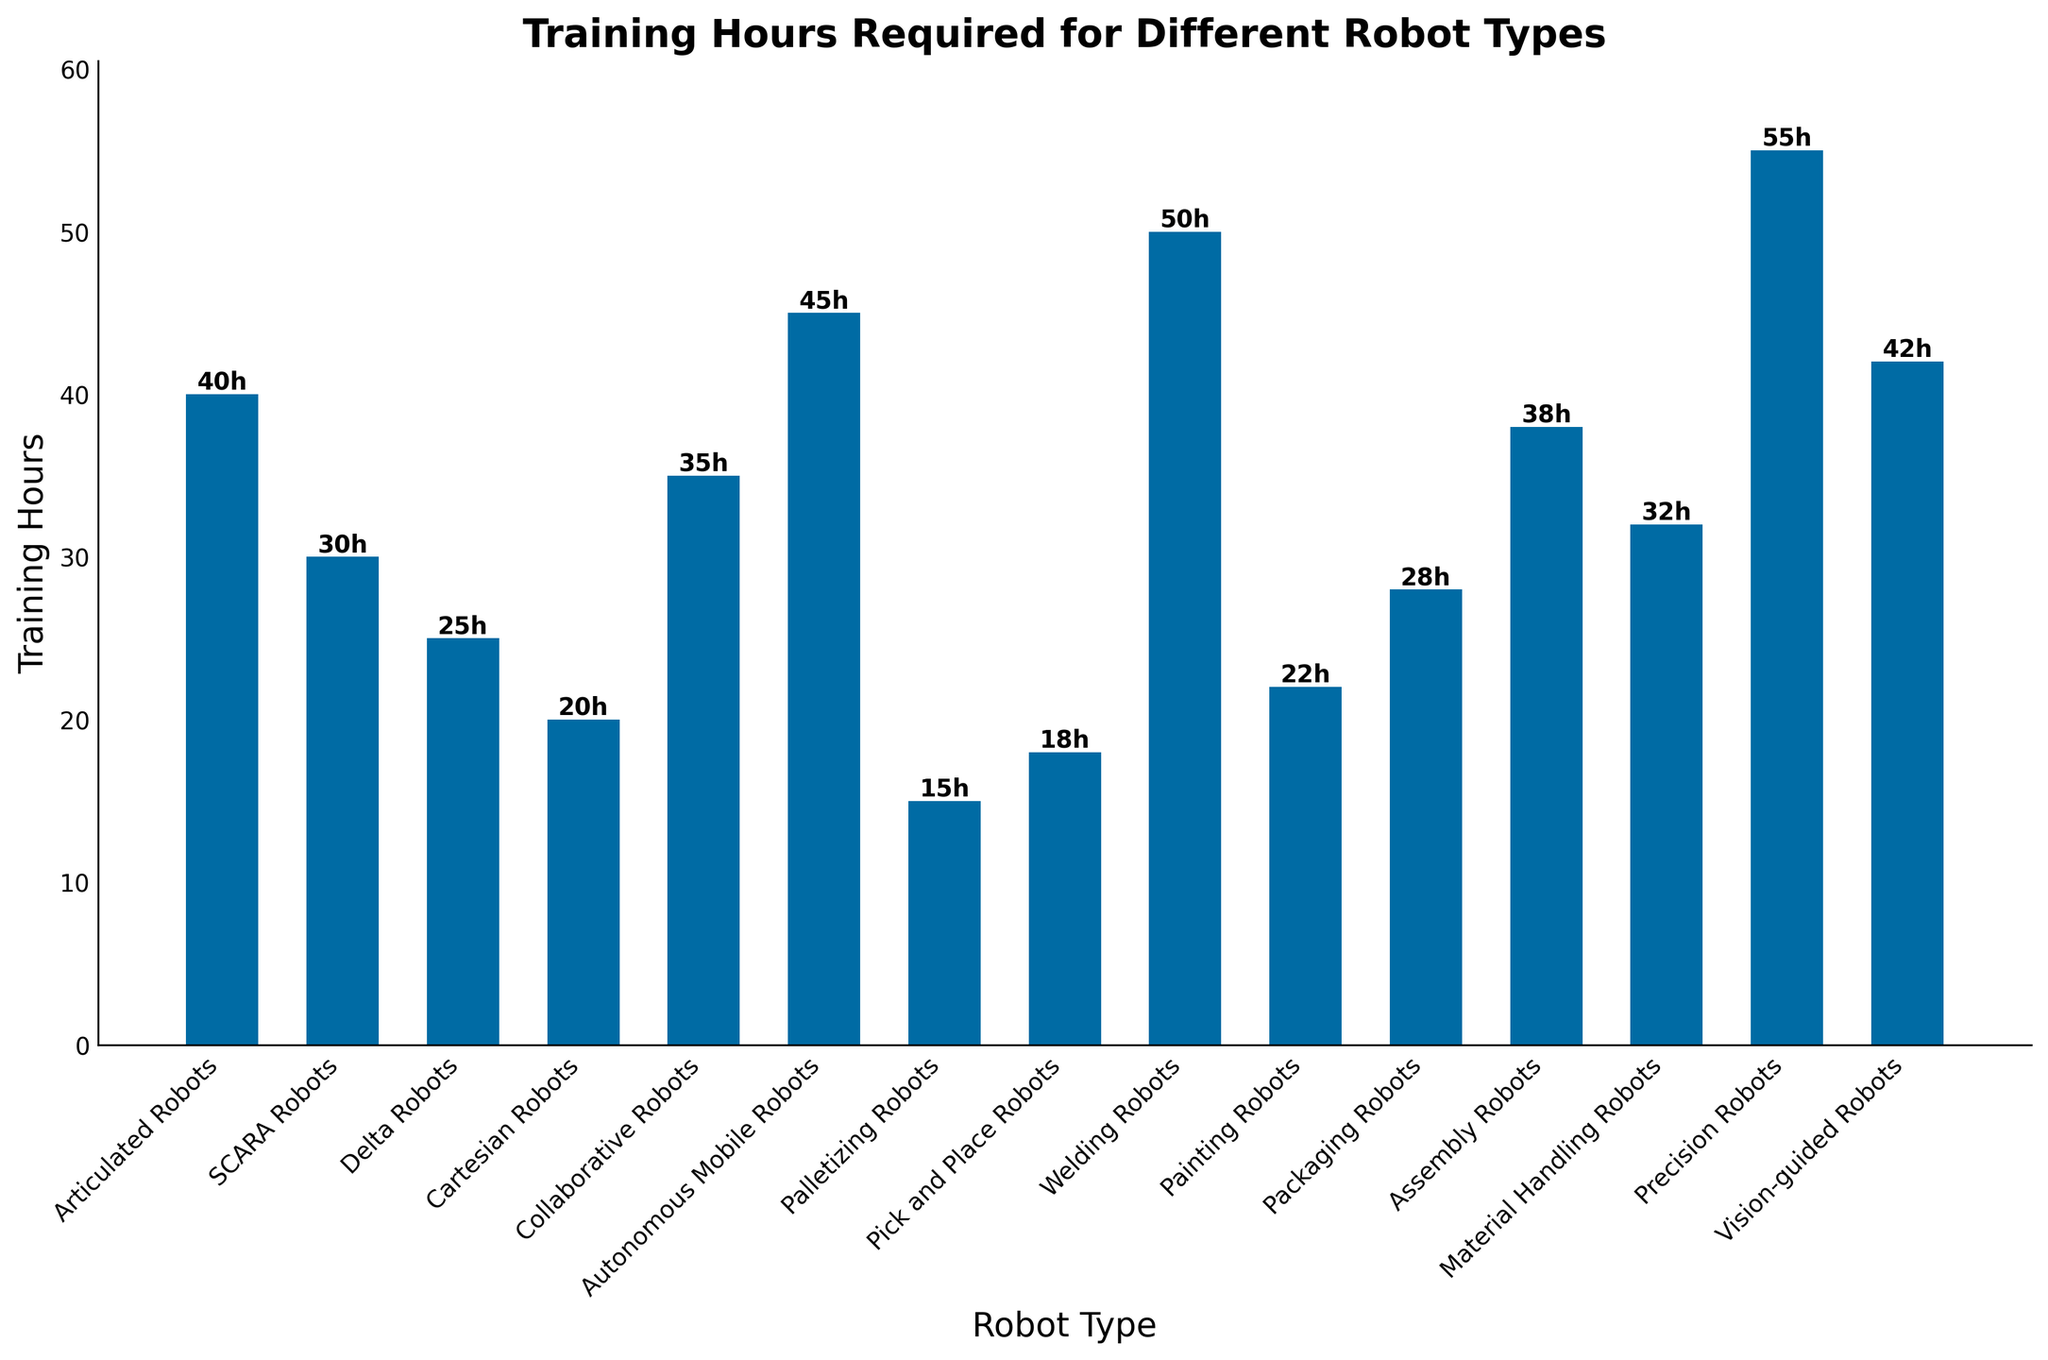Which robot type requires the least training hours? The shortest bar corresponds to the robot type with the fewest training hours. Palletizing Robots is depicted with the shortest bar at 15 hours.
Answer: Palletizing Robots Which robot type requires the most training hours? The tallest bar corresponds to the robot type with the most training hours. Precision Robots is depicted with the tallest bar at 55 hours.
Answer: Precision Robots How many more training hours are required for Autonomous Mobile Robots compared to Pick and Place Robots? First, find the heights of the bars for Autonomous Mobile Robots (45 hours) and Pick and Place Robots (18 hours). Then, subtract the shorter bar's height from the taller bar's height: 45 - 18.
Answer: 27 What is the total number of training hours required for SCARA Robots, Delta Robots, and Cartesian Robots combined? Add the heights of the corresponding bars for SCARA Robots (30 hours), Delta Robots (25 hours), and Cartesian Robots (20 hours). The sum is 30 + 25 + 20.
Answer: 75 Is the training required for Assembly Robots more or less than that for Material Handling Robots, and by how much? Find the heights of the bars for Assembly Robots (38 hours) and Material Handling Robots (32 hours). Then subtract the height of one bar from the other: 38 - 32.
Answer: More by 6 hours Which robot types require training hours between 20 and 30 hours inclusive? Identify the bars with heights in the range of 20 to 30 hours. These are Cartesian Robots (20), Painting Robots (22), Packaging Robots (28), and Delta Robots (25).
Answer: Cartesian Robots, Painting Robots, Packaging Robots, Delta Robots What is the average training hours required for Collaborative Robots, Autonomous Mobile Robots, Palletizing Robots, and Pick and Place Robots? Add the heights of the bars for Collaborative Robots (35 hours), Autonomous Mobile Robots (45 hours), Palletizing Robots (15 hours), and Pick and Place Robots (18 hours). Divide their sum by 4. (35 + 45 + 15 + 18) / 4.
Answer: 28.25 What percentage of the total training hours do Welding Robots require? Calculate the sum of all training hours. Individual sums: 40 + 30 + 25 + 20 + 35 + 45 + 15 + 18 + 50 + 22 + 28 + 38 + 32 + 55 + 42 = 495 hours. Then compute (50 / 495) * 100.
Answer: 10.1% Which two robot types have the closest training hours and what are their values? Identify the bars with training hours that are closest in value. Collaborative Robots (35 hours) and Material Handling Robots (32 hours) have a difference of 3 hours which is the least among all pairs.
Answer: Collaborative Robots (35), Material Handling Robots (32) 